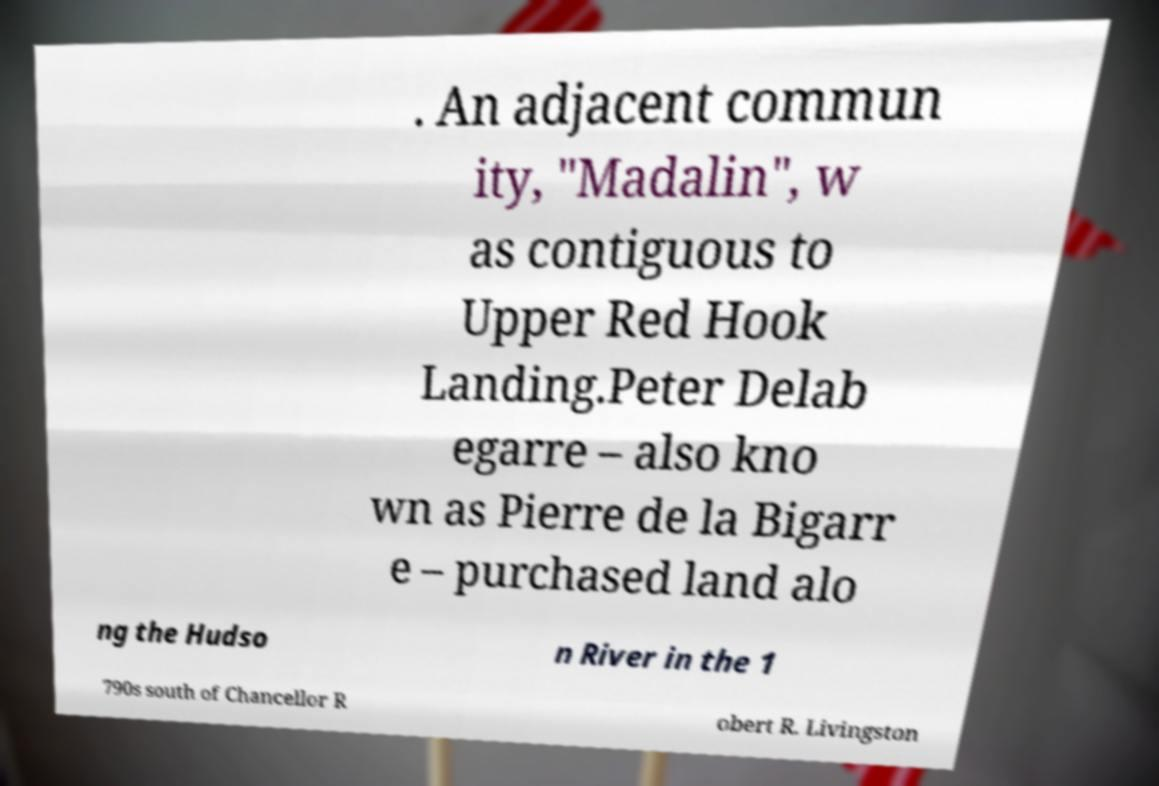Please read and relay the text visible in this image. What does it say? . An adjacent commun ity, "Madalin", w as contiguous to Upper Red Hook Landing.Peter Delab egarre – also kno wn as Pierre de la Bigarr e – purchased land alo ng the Hudso n River in the 1 790s south of Chancellor R obert R. Livingston 